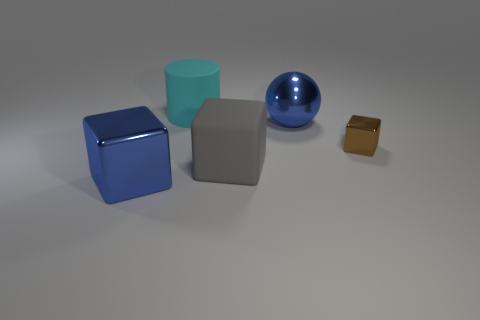Add 3 cyan things. How many cyan things are left? 4 Add 1 metallic balls. How many metallic balls exist? 2 Add 2 small yellow metallic cylinders. How many objects exist? 7 Subtract all blue blocks. How many blocks are left? 2 Subtract all large gray matte blocks. How many blocks are left? 2 Subtract 1 gray cubes. How many objects are left? 4 Subtract all balls. How many objects are left? 4 Subtract 1 spheres. How many spheres are left? 0 Subtract all red blocks. Subtract all cyan cylinders. How many blocks are left? 3 Subtract all purple cylinders. How many brown cubes are left? 1 